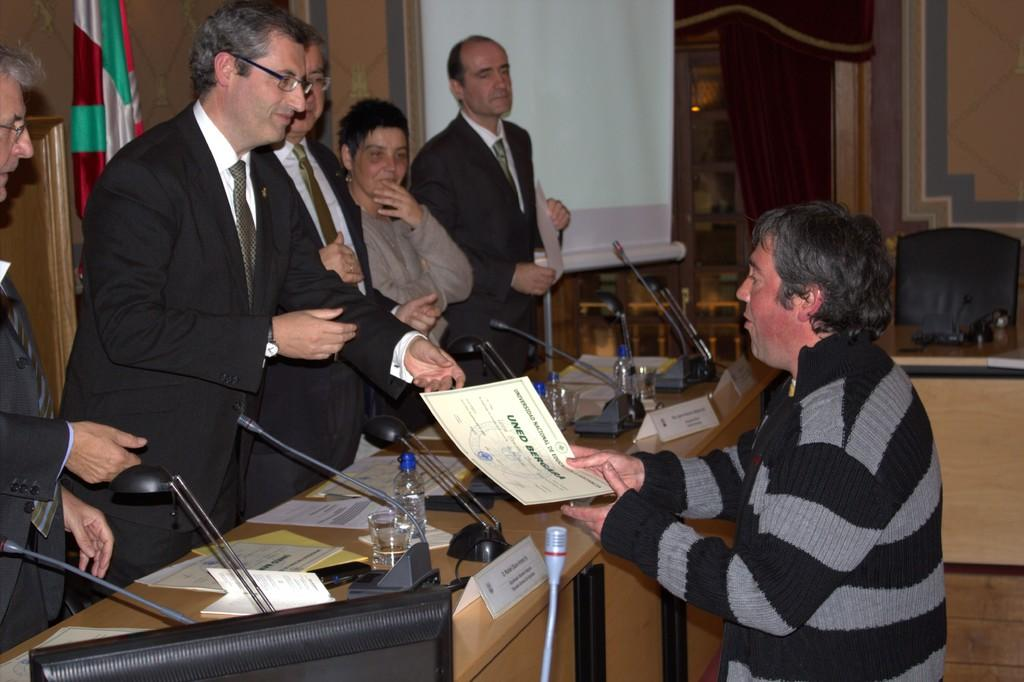Provide a one-sentence caption for the provided image. One man hands a certificate with the text "Uned Bergara" to another man. 